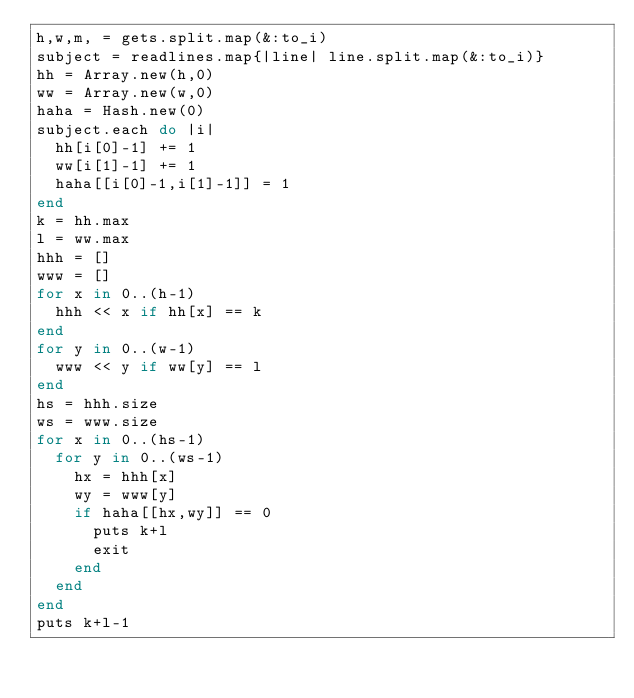<code> <loc_0><loc_0><loc_500><loc_500><_Ruby_>h,w,m, = gets.split.map(&:to_i)
subject = readlines.map{|line| line.split.map(&:to_i)}
hh = Array.new(h,0)
ww = Array.new(w,0)
haha = Hash.new(0)
subject.each do |i|
  hh[i[0]-1] += 1
  ww[i[1]-1] += 1
  haha[[i[0]-1,i[1]-1]] = 1
end
k = hh.max
l = ww.max
hhh = []
www = []
for x in 0..(h-1)
  hhh << x if hh[x] == k
end
for y in 0..(w-1)
  www << y if ww[y] == l
end
hs = hhh.size
ws = www.size
for x in 0..(hs-1)
  for y in 0..(ws-1)
    hx = hhh[x]
    wy = www[y]
    if haha[[hx,wy]] == 0
      puts k+l
      exit
    end
  end
end
puts k+l-1</code> 